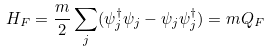<formula> <loc_0><loc_0><loc_500><loc_500>H _ { F } = \frac { m } { 2 } \sum _ { j } ( \psi _ { j } ^ { \dagger } \psi _ { j } - \psi _ { j } \psi _ { j } ^ { \dagger } ) = m Q _ { F }</formula> 